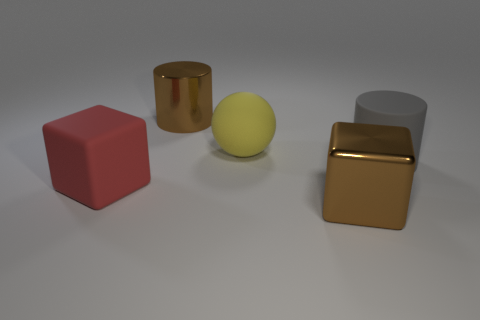Add 2 green rubber objects. How many objects exist? 7 Subtract all cylinders. How many objects are left? 3 Add 4 large red metal objects. How many large red metal objects exist? 4 Subtract 0 yellow cylinders. How many objects are left? 5 Subtract all brown things. Subtract all yellow balls. How many objects are left? 2 Add 3 matte things. How many matte things are left? 6 